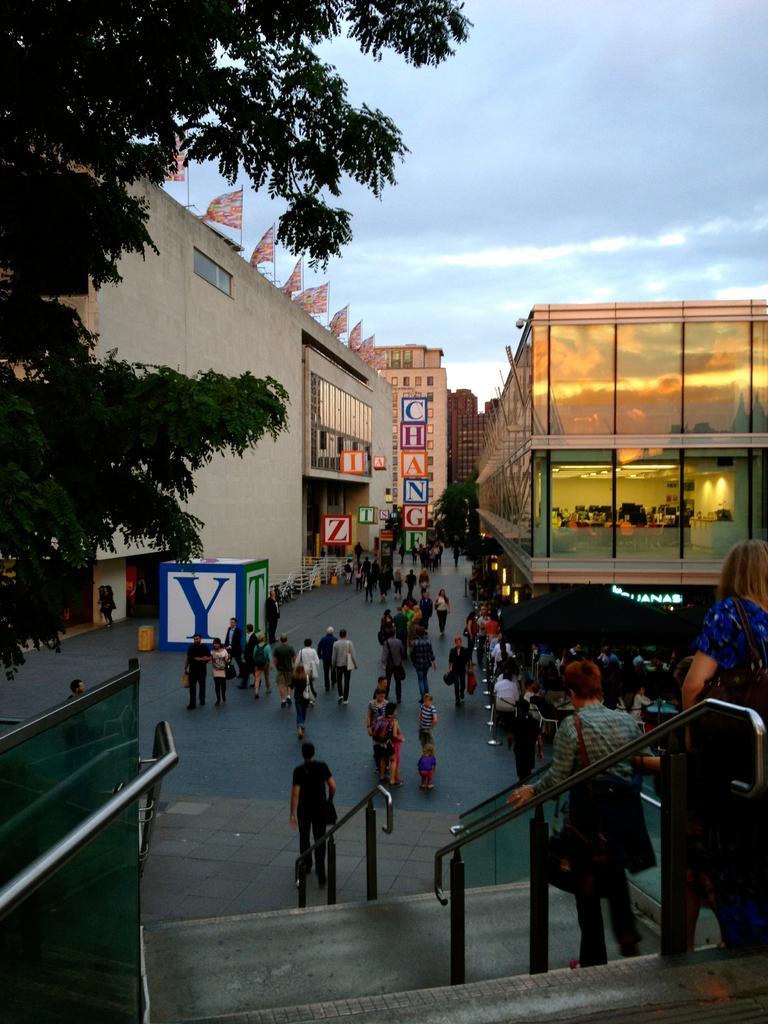Can you describe this image briefly? In this image, on the left side there is a tree and a building, on that building there are flags, in the bottom right there is a roof, in the background there is the sky. 